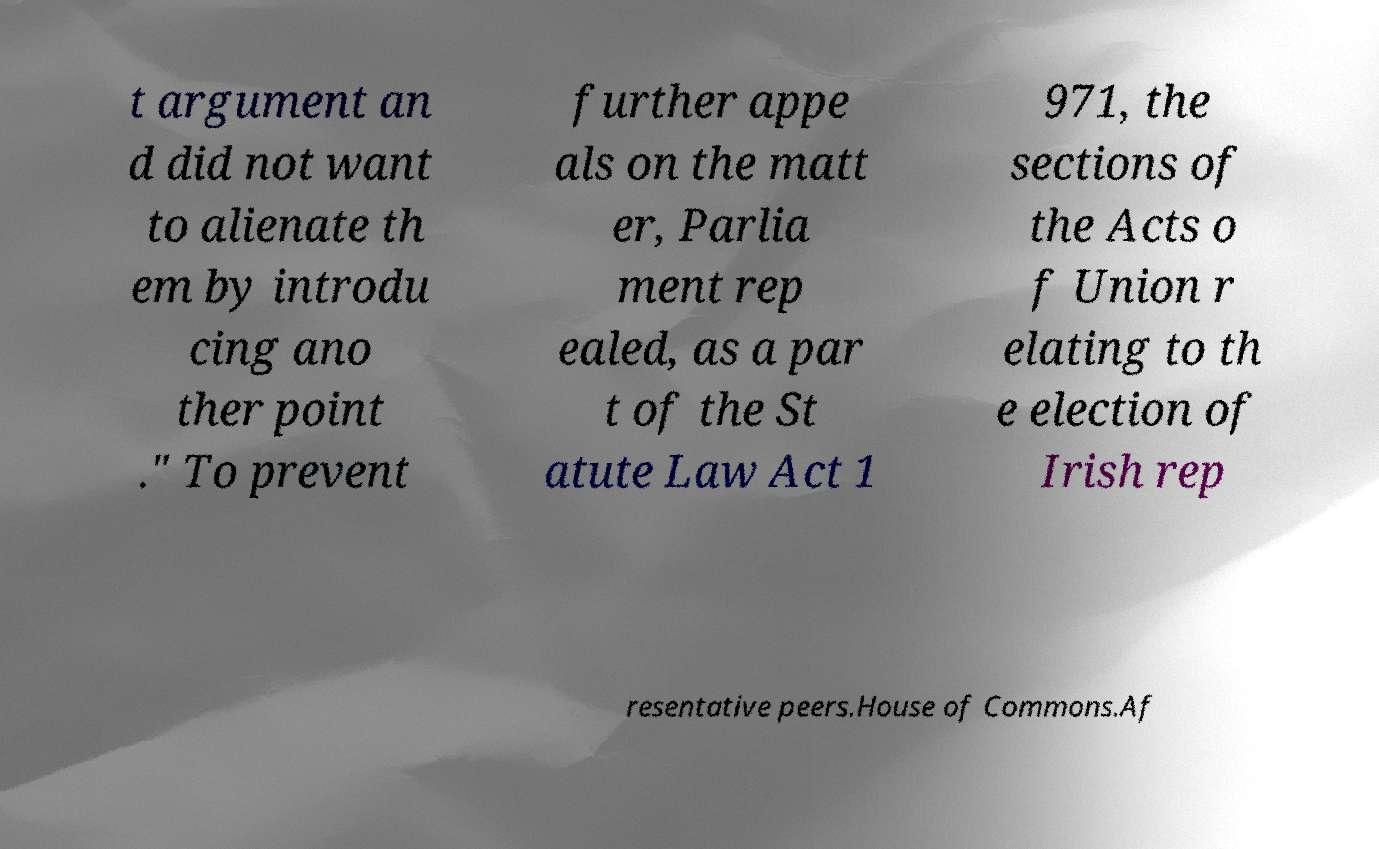Could you assist in decoding the text presented in this image and type it out clearly? t argument an d did not want to alienate th em by introdu cing ano ther point ." To prevent further appe als on the matt er, Parlia ment rep ealed, as a par t of the St atute Law Act 1 971, the sections of the Acts o f Union r elating to th e election of Irish rep resentative peers.House of Commons.Af 